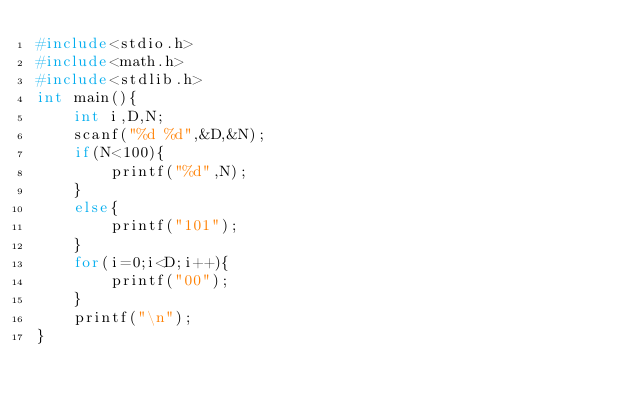<code> <loc_0><loc_0><loc_500><loc_500><_C_>#include<stdio.h>
#include<math.h>
#include<stdlib.h>
int main(){
	int i,D,N;
	scanf("%d %d",&D,&N);
	if(N<100){
		printf("%d",N);
	}
	else{
		printf("101");
	}
	for(i=0;i<D;i++){
		printf("00");
	}
	printf("\n");
}</code> 